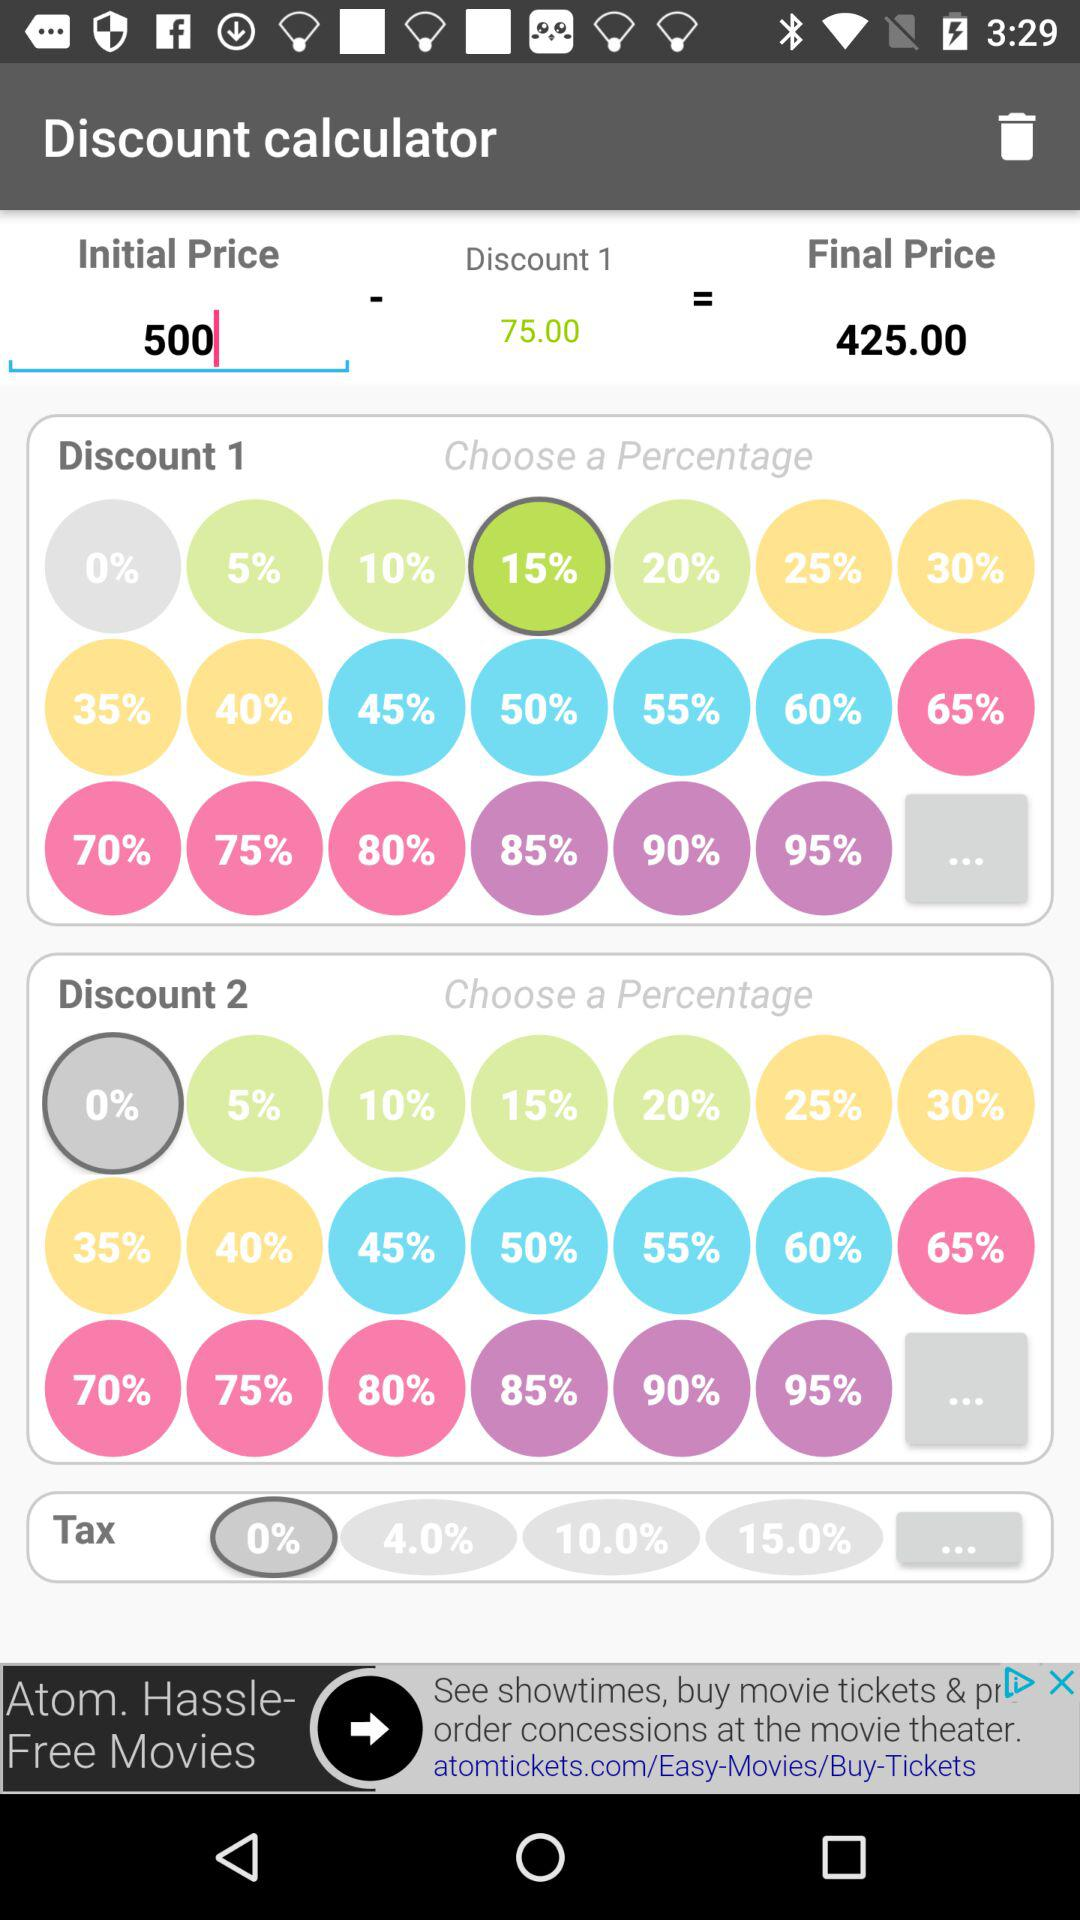How much of a discount percentage is selected for discount 2? The discount percentage selected for discount 2 is 0. 